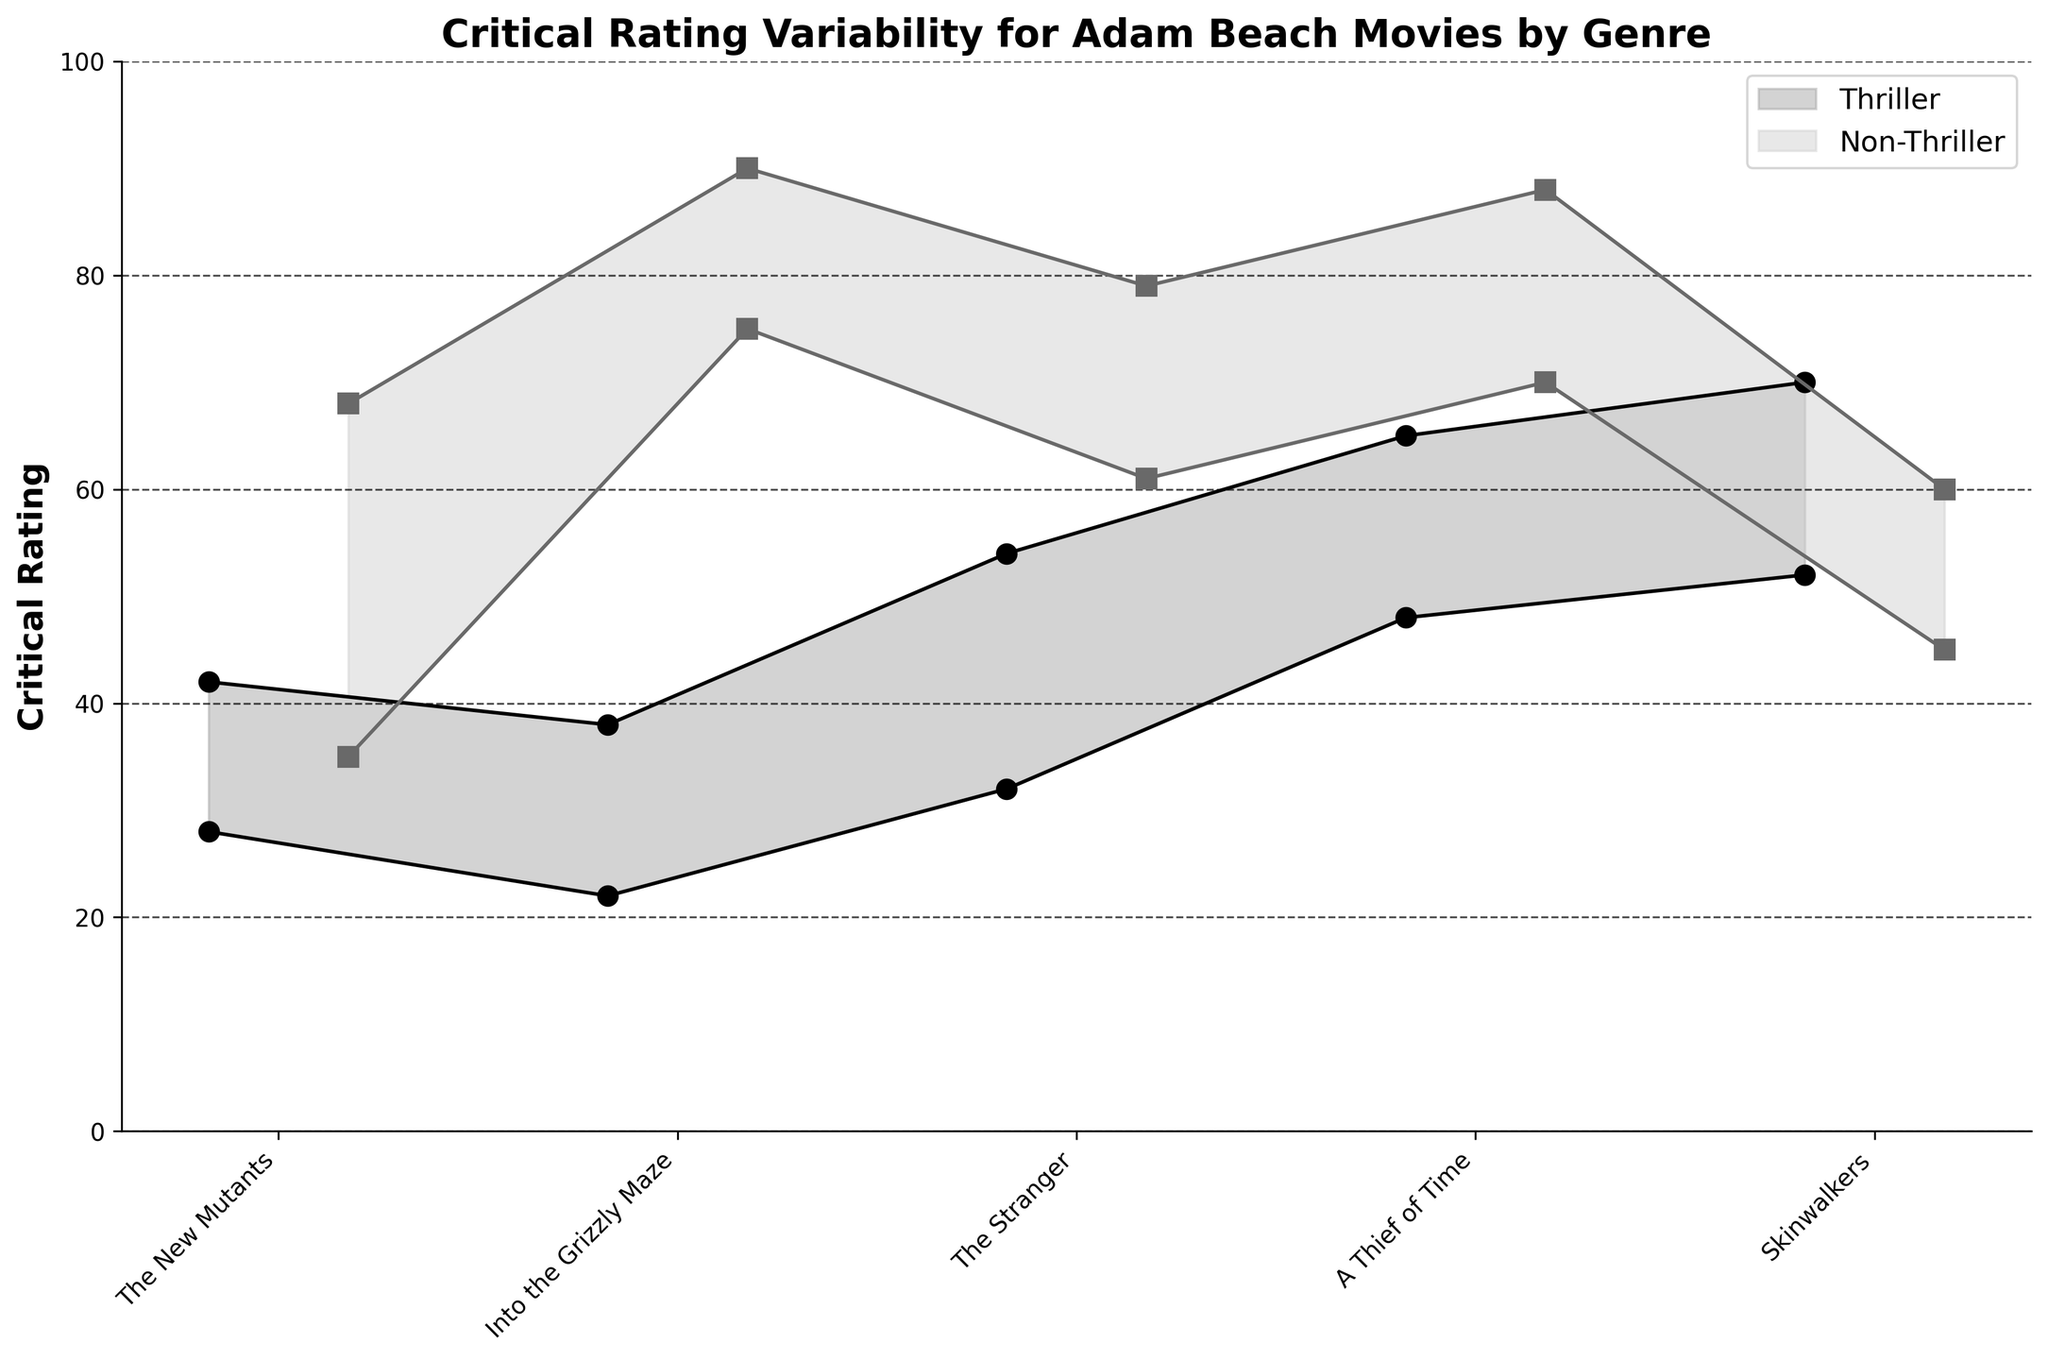What's the title of the figure? The title of the figure is usually written at the top in bold letters.
Answer: Critical Rating Variability for Adam Beach Movies by Genre How is the critical rating range for thrillers represented visually? The critical rating range for thrillers is shown as a shaded area between two lines. The lines represent the minimum and maximum ratings with circles at data points.
Answer: Shaded area between two lines with circles at data points What is the minimum critical rating for "The New Mutants"? Locate "The New Mutants" on the x-axis and observe the bottom of the shaded area or the bottom circle for this movie.
Answer: 28 Which genre has a wider variability in ratings for most movies? Observe the width of the shaded areas for both thriller and non-thriller movies.
Answer: Non-Thriller Which movie has the highest maximum rating among non-thrillers? Look at the top of the shaded areas or the top data points for non-thriller movies and find the highest value.
Answer: Smoke Signals What is the average maximum rating for thriller movies? Sum the maximum ratings for all thriller movies and divide by the number of thriller movies. Ratings: (42 + 38 + 54 + 65 + 70) / 5.
Answer: 53.8 How much higher is the maximum rating of "Smoke Signals" compared to "The New Mutants"? Find the difference between the maximum rating of "Smoke Signals" (non-thriller) and "The New Mutants" (thriller).
Answer: 48 What is the title of the movie with the largest difference between its minimum and maximum ratings? Calculate the range (max - min) for each movie and identify the movie with the largest range.
Answer: Skinwalkers Which thriller movie has the smallest range in critical ratings? Find the thriller movie with the smallest difference between its maximum and minimum ratings.
Answer: The New Mutants Do any non-thriller movies have both higher minimum and maximum ratings than any thriller movie? Compare the maximum and minimum ratings of all non-thriller movies with those of all thriller movies to check any non-thriller meets the condition.
Answer: Yes 